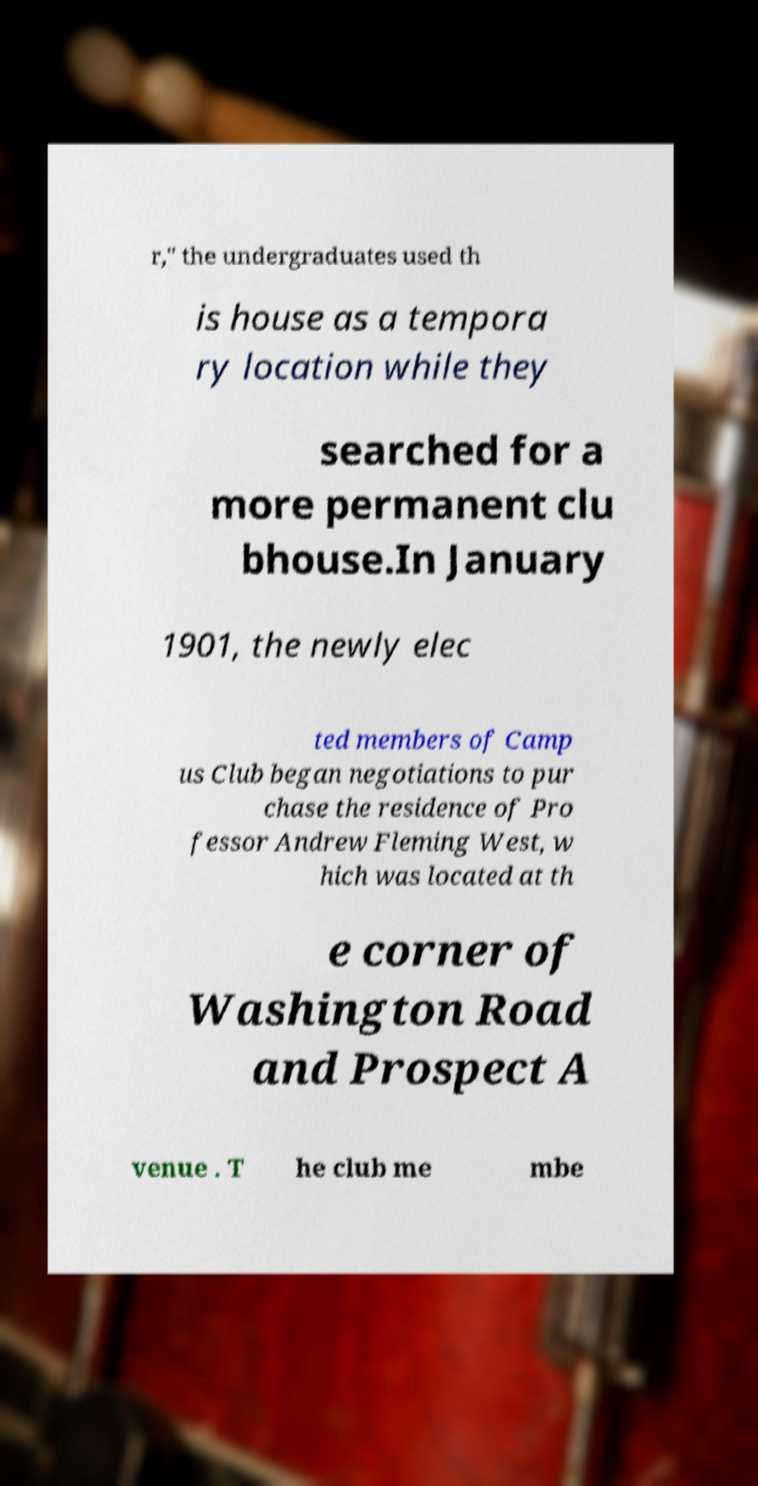There's text embedded in this image that I need extracted. Can you transcribe it verbatim? r," the undergraduates used th is house as a tempora ry location while they searched for a more permanent clu bhouse.In January 1901, the newly elec ted members of Camp us Club began negotiations to pur chase the residence of Pro fessor Andrew Fleming West, w hich was located at th e corner of Washington Road and Prospect A venue . T he club me mbe 